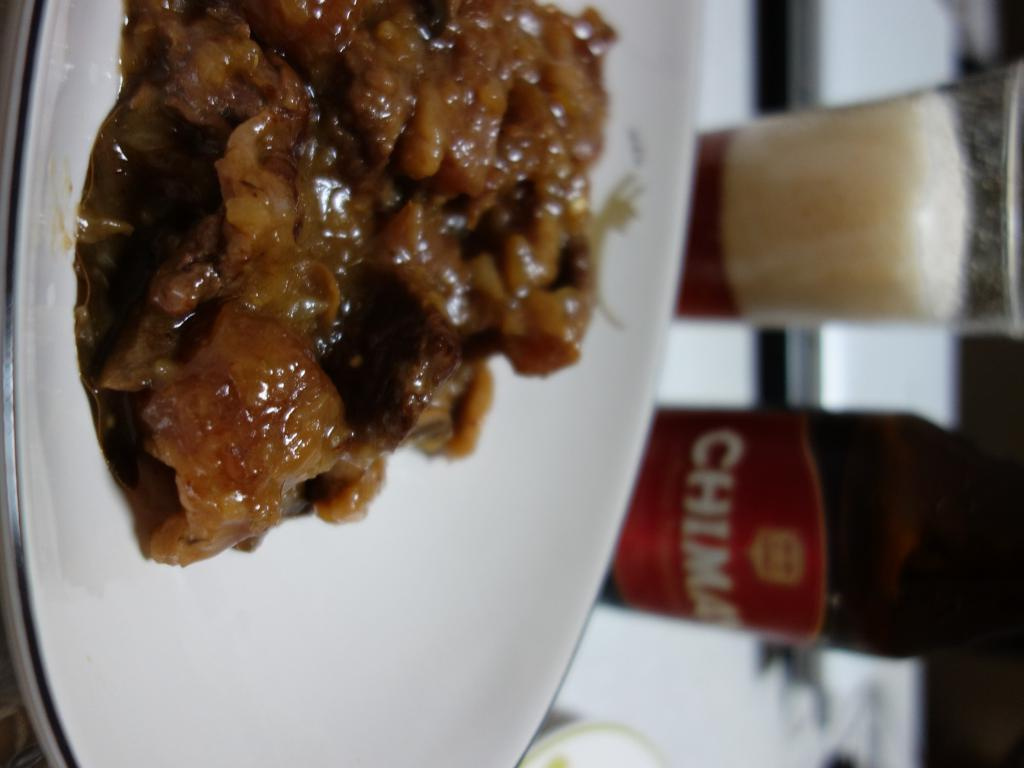What type of food can be seen in the image? The food in the image is brown in color. How is the food presented in the image? The food is in a plate. What color is the plate? The plate is white in color. What other objects can be seen in the background of the image? There is a bottle and a glass in the background of the image. What is the weather like in the image? The provided facts do not mention any information about the weather, so it cannot be determined from the image. 